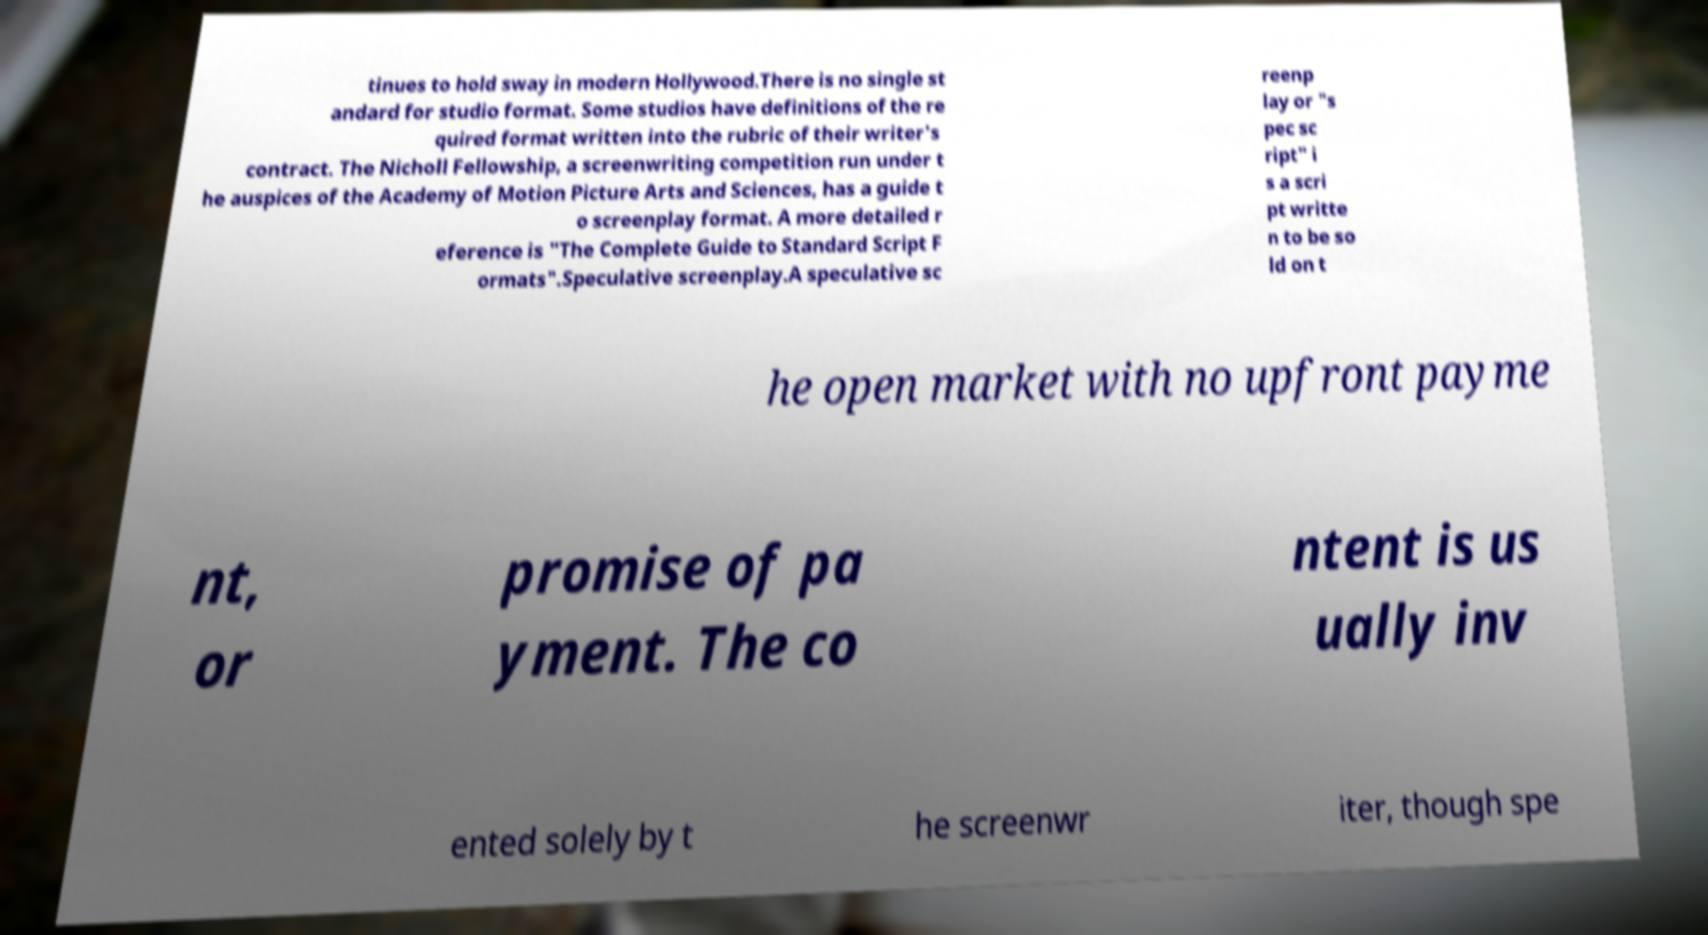For documentation purposes, I need the text within this image transcribed. Could you provide that? tinues to hold sway in modern Hollywood.There is no single st andard for studio format. Some studios have definitions of the re quired format written into the rubric of their writer's contract. The Nicholl Fellowship, a screenwriting competition run under t he auspices of the Academy of Motion Picture Arts and Sciences, has a guide t o screenplay format. A more detailed r eference is "The Complete Guide to Standard Script F ormats".Speculative screenplay.A speculative sc reenp lay or "s pec sc ript" i s a scri pt writte n to be so ld on t he open market with no upfront payme nt, or promise of pa yment. The co ntent is us ually inv ented solely by t he screenwr iter, though spe 